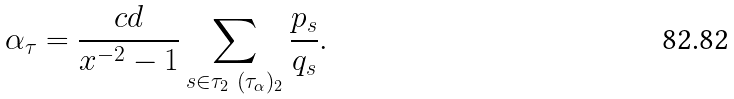<formula> <loc_0><loc_0><loc_500><loc_500>\alpha _ { \tau } = \frac { c d } { x ^ { - 2 } - 1 } \sum _ { s \in \tau _ { 2 } \ ( \tau _ { \alpha } ) _ { 2 } } \frac { p _ { s } } { q _ { s } } .</formula> 